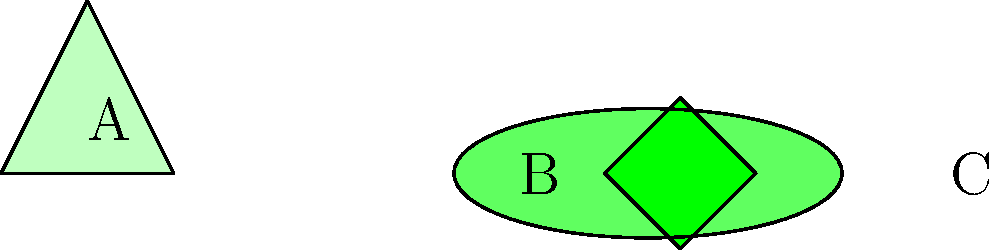The image shows three different leaf shapes: A (broad and triangular), B (long and narrow), and C (small and diamond-shaped). Which leaf shape would likely be most efficient for water conservation in a dry environment? To answer this question, we need to consider the relationship between leaf shape, surface area, and water conservation:

1. Surface area to volume ratio: Leaves with a lower surface area to volume ratio lose less water through transpiration.

2. Leaf A (broad and triangular):
   - Large surface area
   - Increased exposure to sunlight and air
   - Higher water loss through transpiration

3. Leaf B (long and narrow):
   - Reduced surface area compared to leaf A
   - Less exposure to direct sunlight
   - Moderate water conservation

4. Leaf C (small and diamond-shaped):
   - Smallest surface area among the three
   - Minimal exposure to sunlight and air
   - Lowest water loss through transpiration

5. Adaptation to dry environments:
   - Plants in arid conditions often develop smaller leaves to conserve water
   - Reduced surface area minimizes water loss while still allowing for photosynthesis

Therefore, leaf C, with its small size and diamond shape, would likely be the most efficient for water conservation in a dry environment.
Answer: Leaf C (small and diamond-shaped) 